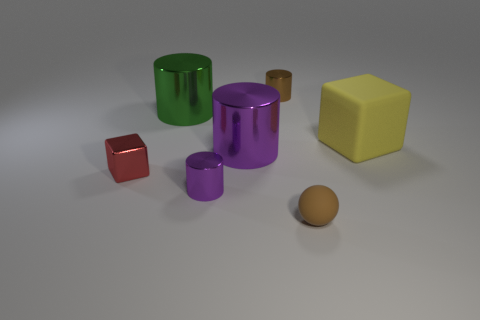Subtract all red cylinders. Subtract all blue cubes. How many cylinders are left? 4 Add 2 large blue matte cylinders. How many objects exist? 9 Subtract all spheres. How many objects are left? 6 Add 4 small purple shiny cylinders. How many small purple shiny cylinders are left? 5 Add 6 big green metal cylinders. How many big green metal cylinders exist? 7 Subtract 0 cyan blocks. How many objects are left? 7 Subtract all big purple metallic cylinders. Subtract all tiny brown metallic cylinders. How many objects are left? 5 